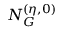Convert formula to latex. <formula><loc_0><loc_0><loc_500><loc_500>N _ { G } ^ { ( \eta , 0 ) }</formula> 